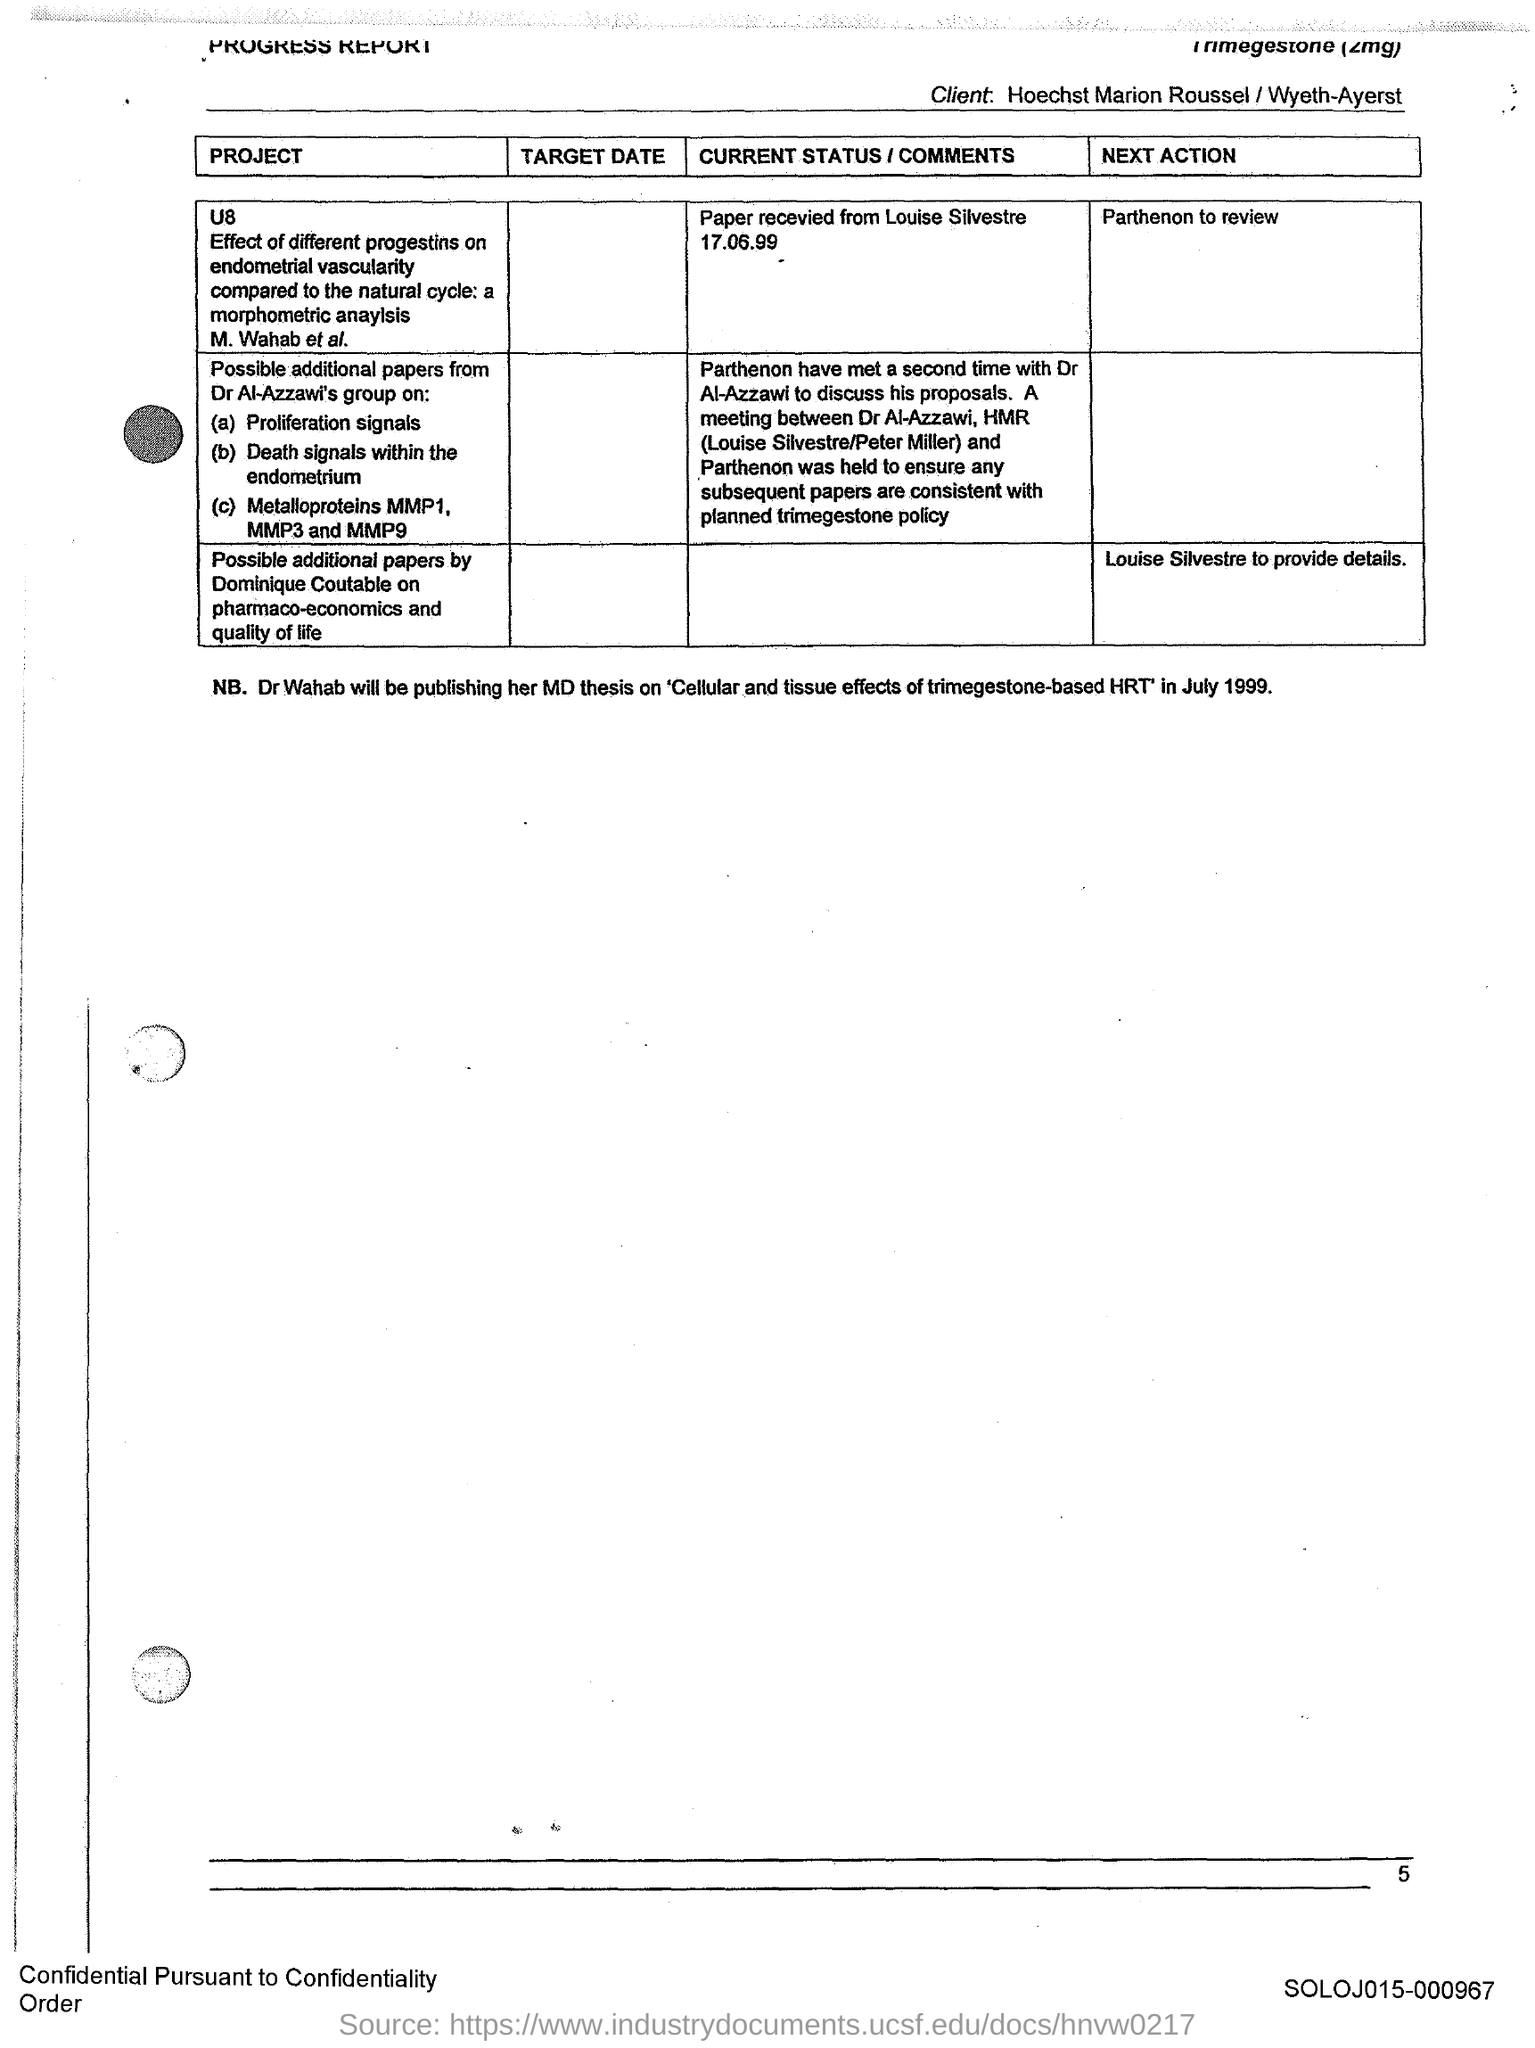What is the Page Number?
Your response must be concise. 5. 